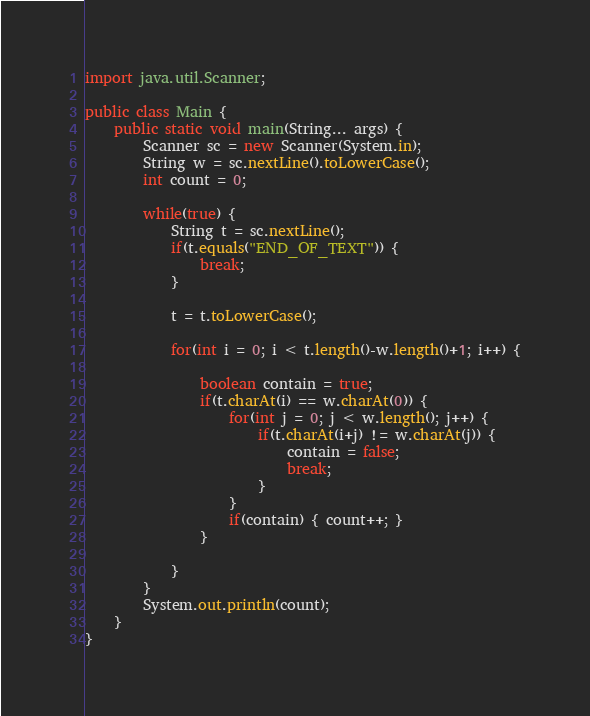<code> <loc_0><loc_0><loc_500><loc_500><_Java_>import java.util.Scanner;

public class Main {
    public static void main(String... args) {
        Scanner sc = new Scanner(System.in);
        String w = sc.nextLine().toLowerCase();
        int count = 0;

        while(true) {
        	String t = sc.nextLine();
        	if(t.equals("END_OF_TEXT")) {
        		break;
        	}
        	
        	t = t.toLowerCase();

        	for(int i = 0; i < t.length()-w.length()+1; i++) {

        		boolean contain = true;
        		if(t.charAt(i) == w.charAt(0)) {
        			for(int j = 0; j < w.length(); j++) {
        				if(t.charAt(i+j) != w.charAt(j)) {
        					contain = false;
        					break;
        				}
        			}
        			if(contain) { count++; }
        		}

        	}
        }
        System.out.println(count);
    }
}
</code> 